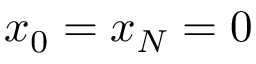<formula> <loc_0><loc_0><loc_500><loc_500>x _ { 0 } = x _ { N } = 0</formula> 